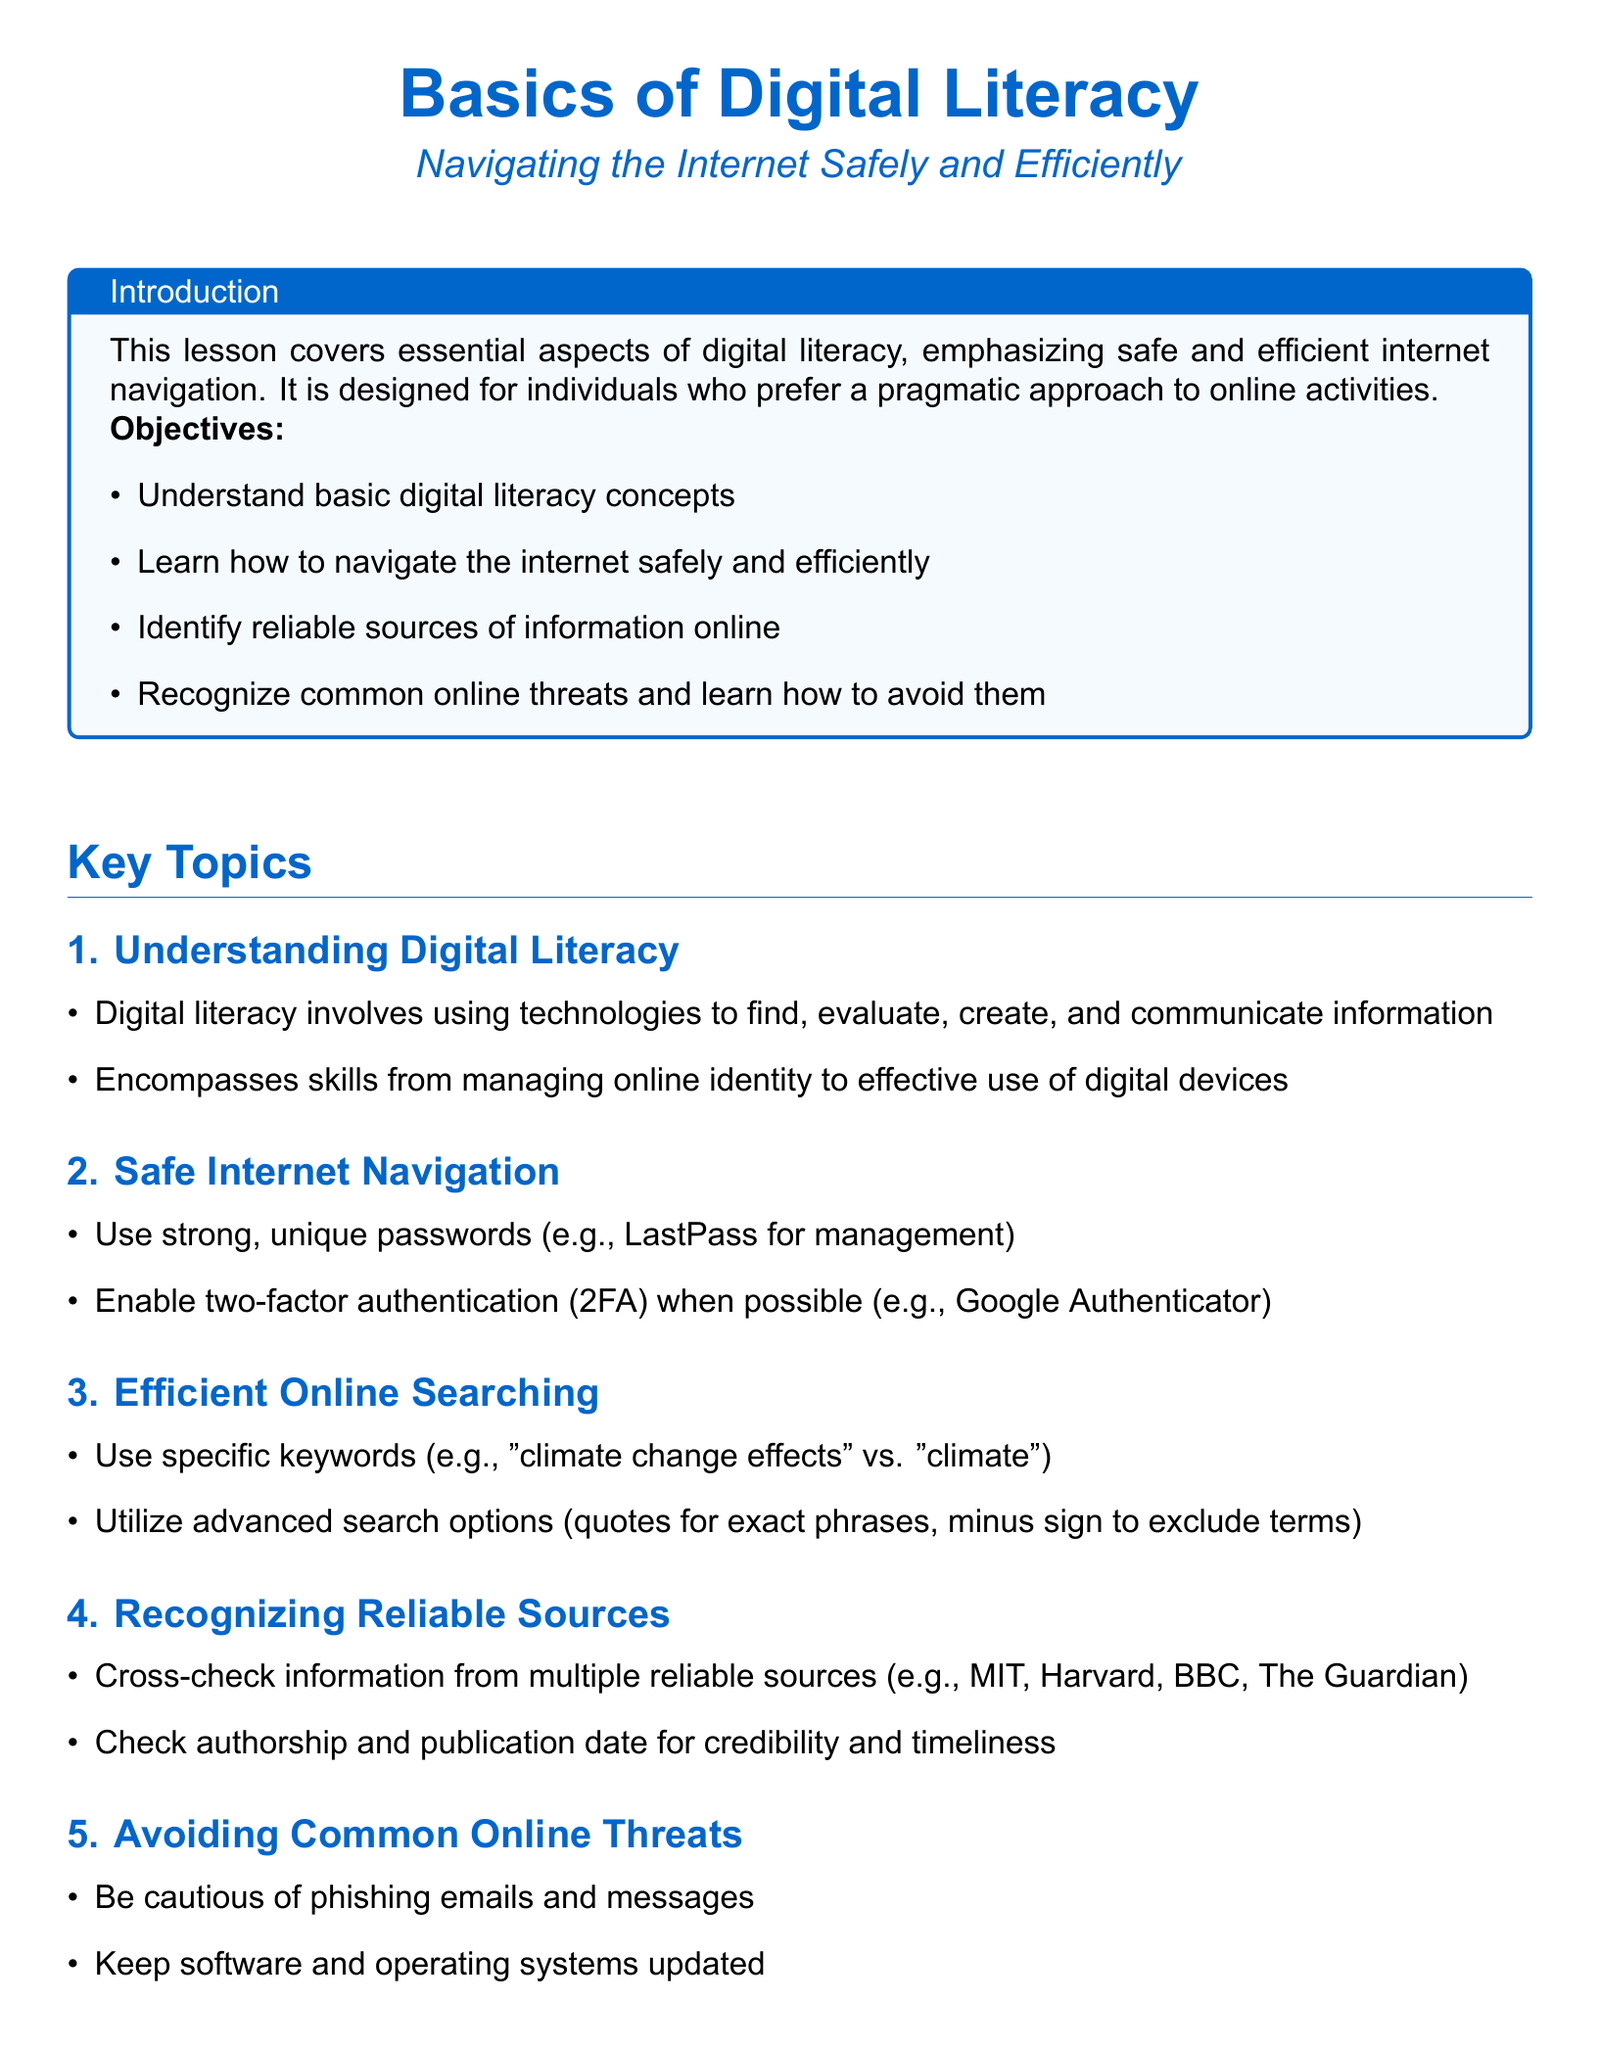what are the main objectives of the lesson? The objectives include understanding basic digital literacy concepts, learning to navigate the internet safely and efficiently, identifying reliable sources of information online, and recognizing common online threats.
Answer: understanding basic digital literacy concepts, learning to navigate the internet safely and efficiently, identifying reliable sources of information online, recognizing common online threats what is digital literacy? Digital literacy involves using technologies to find, evaluate, create, and communicate information and encompasses skills from managing online identity to effective use of digital devices.
Answer: using technologies to find, evaluate, create, and communicate information name a way to enable additional security on accounts. The document suggests enabling two-factor authentication when possible.
Answer: enable two-factor authentication which resource is provided for online safety tips? The resource for online safety tips mentioned is the Federal Trade Commission (FTC).
Answer: FTC how can one check the credibility of an online source? One can check credibility by cross-checking information from multiple reliable sources, checking authorship, and publication date.
Answer: cross-checking information from multiple reliable sources what should be kept updated to avoid online threats? Keeping software and operating systems updated is essential to avoid online threats.
Answer: software and operating systems what type of document is this? This document is a lesson plan.
Answer: lesson plan 